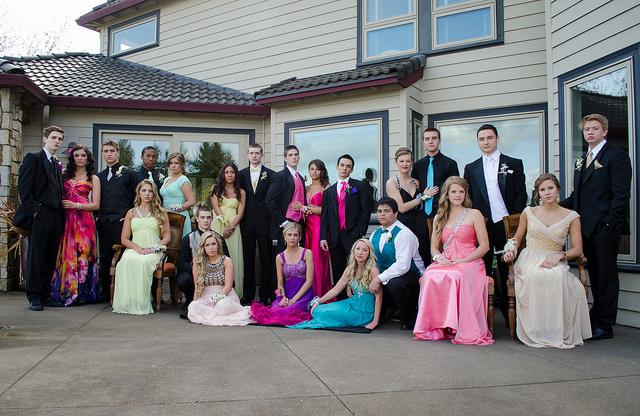Why is everyone posed so ornately? Please explain your reasoning. wedding photo. The group of people are posing together as they are dressed up to go to a wedding. 